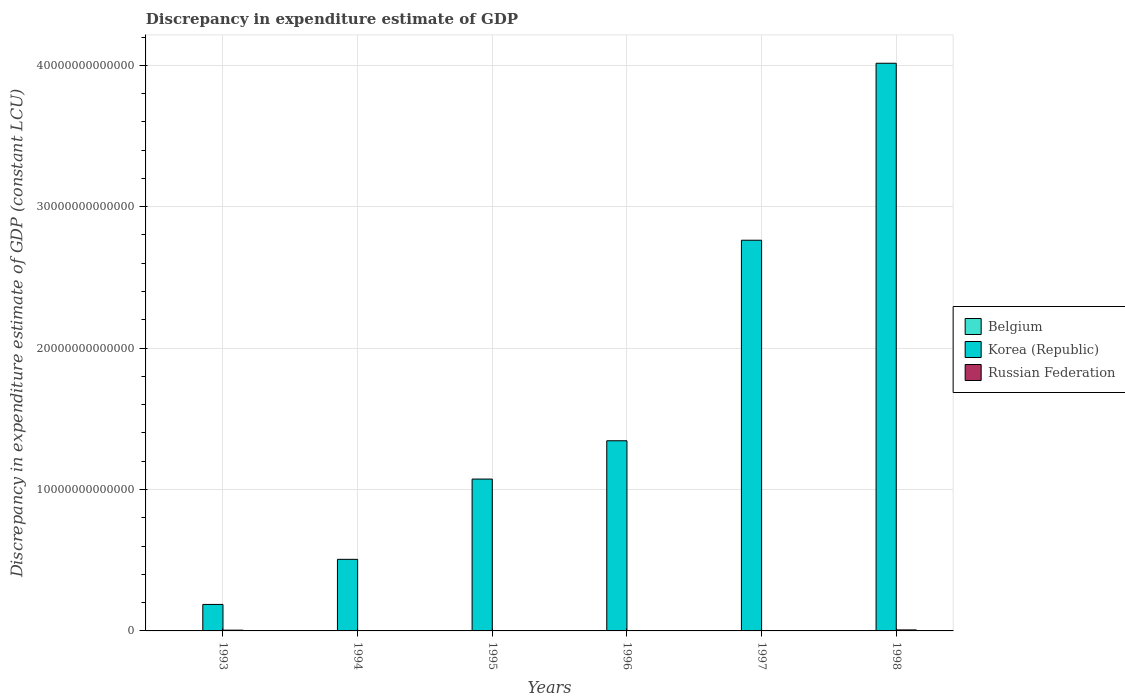How many different coloured bars are there?
Keep it short and to the point. 2. How many bars are there on the 4th tick from the left?
Provide a short and direct response. 1. What is the discrepancy in expenditure estimate of GDP in Belgium in 1996?
Keep it short and to the point. 0. Across all years, what is the maximum discrepancy in expenditure estimate of GDP in Russian Federation?
Your answer should be compact. 7.15e+1. Across all years, what is the minimum discrepancy in expenditure estimate of GDP in Korea (Republic)?
Your answer should be very brief. 1.87e+12. What is the difference between the discrepancy in expenditure estimate of GDP in Russian Federation in 1993 and that in 1998?
Offer a terse response. -1.83e+1. What is the difference between the discrepancy in expenditure estimate of GDP in Korea (Republic) in 1993 and the discrepancy in expenditure estimate of GDP in Belgium in 1996?
Your response must be concise. 1.87e+12. What is the average discrepancy in expenditure estimate of GDP in Russian Federation per year?
Ensure brevity in your answer.  2.37e+1. In the year 1993, what is the difference between the discrepancy in expenditure estimate of GDP in Korea (Republic) and discrepancy in expenditure estimate of GDP in Russian Federation?
Your answer should be compact. 1.82e+12. What is the ratio of the discrepancy in expenditure estimate of GDP in Korea (Republic) in 1994 to that in 1996?
Keep it short and to the point. 0.38. Is the discrepancy in expenditure estimate of GDP in Korea (Republic) in 1996 less than that in 1997?
Offer a terse response. Yes. What is the difference between the highest and the second highest discrepancy in expenditure estimate of GDP in Korea (Republic)?
Keep it short and to the point. 1.25e+13. What is the difference between the highest and the lowest discrepancy in expenditure estimate of GDP in Russian Federation?
Provide a short and direct response. 7.15e+1. Is the sum of the discrepancy in expenditure estimate of GDP in Russian Federation in 1997 and 1998 greater than the maximum discrepancy in expenditure estimate of GDP in Belgium across all years?
Keep it short and to the point. Yes. Is it the case that in every year, the sum of the discrepancy in expenditure estimate of GDP in Belgium and discrepancy in expenditure estimate of GDP in Russian Federation is greater than the discrepancy in expenditure estimate of GDP in Korea (Republic)?
Offer a terse response. No. Are all the bars in the graph horizontal?
Give a very brief answer. No. How many years are there in the graph?
Provide a succinct answer. 6. What is the difference between two consecutive major ticks on the Y-axis?
Your response must be concise. 1.00e+13. Does the graph contain grids?
Provide a short and direct response. Yes. What is the title of the graph?
Your response must be concise. Discrepancy in expenditure estimate of GDP. Does "Other small states" appear as one of the legend labels in the graph?
Your answer should be compact. No. What is the label or title of the Y-axis?
Your response must be concise. Discrepancy in expenditure estimate of GDP (constant LCU). What is the Discrepancy in expenditure estimate of GDP (constant LCU) in Belgium in 1993?
Make the answer very short. 0. What is the Discrepancy in expenditure estimate of GDP (constant LCU) of Korea (Republic) in 1993?
Your answer should be very brief. 1.87e+12. What is the Discrepancy in expenditure estimate of GDP (constant LCU) in Russian Federation in 1993?
Your answer should be compact. 5.32e+1. What is the Discrepancy in expenditure estimate of GDP (constant LCU) in Belgium in 1994?
Keep it short and to the point. 0. What is the Discrepancy in expenditure estimate of GDP (constant LCU) in Korea (Republic) in 1994?
Your response must be concise. 5.06e+12. What is the Discrepancy in expenditure estimate of GDP (constant LCU) of Russian Federation in 1994?
Provide a succinct answer. 0. What is the Discrepancy in expenditure estimate of GDP (constant LCU) of Korea (Republic) in 1995?
Provide a short and direct response. 1.07e+13. What is the Discrepancy in expenditure estimate of GDP (constant LCU) in Russian Federation in 1995?
Your answer should be compact. 0. What is the Discrepancy in expenditure estimate of GDP (constant LCU) in Belgium in 1996?
Provide a succinct answer. 0. What is the Discrepancy in expenditure estimate of GDP (constant LCU) in Korea (Republic) in 1996?
Keep it short and to the point. 1.34e+13. What is the Discrepancy in expenditure estimate of GDP (constant LCU) of Korea (Republic) in 1997?
Your answer should be very brief. 2.76e+13. What is the Discrepancy in expenditure estimate of GDP (constant LCU) in Russian Federation in 1997?
Your answer should be compact. 1.78e+1. What is the Discrepancy in expenditure estimate of GDP (constant LCU) in Belgium in 1998?
Give a very brief answer. 0. What is the Discrepancy in expenditure estimate of GDP (constant LCU) in Korea (Republic) in 1998?
Provide a succinct answer. 4.01e+13. What is the Discrepancy in expenditure estimate of GDP (constant LCU) in Russian Federation in 1998?
Your response must be concise. 7.15e+1. Across all years, what is the maximum Discrepancy in expenditure estimate of GDP (constant LCU) in Korea (Republic)?
Your response must be concise. 4.01e+13. Across all years, what is the maximum Discrepancy in expenditure estimate of GDP (constant LCU) in Russian Federation?
Your answer should be very brief. 7.15e+1. Across all years, what is the minimum Discrepancy in expenditure estimate of GDP (constant LCU) in Korea (Republic)?
Offer a very short reply. 1.87e+12. What is the total Discrepancy in expenditure estimate of GDP (constant LCU) in Belgium in the graph?
Make the answer very short. 0. What is the total Discrepancy in expenditure estimate of GDP (constant LCU) of Korea (Republic) in the graph?
Ensure brevity in your answer.  9.89e+13. What is the total Discrepancy in expenditure estimate of GDP (constant LCU) of Russian Federation in the graph?
Keep it short and to the point. 1.42e+11. What is the difference between the Discrepancy in expenditure estimate of GDP (constant LCU) in Korea (Republic) in 1993 and that in 1994?
Your answer should be very brief. -3.19e+12. What is the difference between the Discrepancy in expenditure estimate of GDP (constant LCU) of Korea (Republic) in 1993 and that in 1995?
Provide a short and direct response. -8.87e+12. What is the difference between the Discrepancy in expenditure estimate of GDP (constant LCU) in Korea (Republic) in 1993 and that in 1996?
Offer a very short reply. -1.16e+13. What is the difference between the Discrepancy in expenditure estimate of GDP (constant LCU) of Korea (Republic) in 1993 and that in 1997?
Your answer should be compact. -2.58e+13. What is the difference between the Discrepancy in expenditure estimate of GDP (constant LCU) in Russian Federation in 1993 and that in 1997?
Make the answer very short. 3.54e+1. What is the difference between the Discrepancy in expenditure estimate of GDP (constant LCU) of Korea (Republic) in 1993 and that in 1998?
Your answer should be very brief. -3.83e+13. What is the difference between the Discrepancy in expenditure estimate of GDP (constant LCU) of Russian Federation in 1993 and that in 1998?
Ensure brevity in your answer.  -1.83e+1. What is the difference between the Discrepancy in expenditure estimate of GDP (constant LCU) in Korea (Republic) in 1994 and that in 1995?
Your response must be concise. -5.68e+12. What is the difference between the Discrepancy in expenditure estimate of GDP (constant LCU) in Korea (Republic) in 1994 and that in 1996?
Give a very brief answer. -8.39e+12. What is the difference between the Discrepancy in expenditure estimate of GDP (constant LCU) in Korea (Republic) in 1994 and that in 1997?
Provide a short and direct response. -2.26e+13. What is the difference between the Discrepancy in expenditure estimate of GDP (constant LCU) in Korea (Republic) in 1994 and that in 1998?
Provide a short and direct response. -3.51e+13. What is the difference between the Discrepancy in expenditure estimate of GDP (constant LCU) of Korea (Republic) in 1995 and that in 1996?
Your response must be concise. -2.71e+12. What is the difference between the Discrepancy in expenditure estimate of GDP (constant LCU) in Korea (Republic) in 1995 and that in 1997?
Your response must be concise. -1.69e+13. What is the difference between the Discrepancy in expenditure estimate of GDP (constant LCU) in Korea (Republic) in 1995 and that in 1998?
Keep it short and to the point. -2.94e+13. What is the difference between the Discrepancy in expenditure estimate of GDP (constant LCU) of Korea (Republic) in 1996 and that in 1997?
Provide a short and direct response. -1.42e+13. What is the difference between the Discrepancy in expenditure estimate of GDP (constant LCU) in Korea (Republic) in 1996 and that in 1998?
Make the answer very short. -2.67e+13. What is the difference between the Discrepancy in expenditure estimate of GDP (constant LCU) of Korea (Republic) in 1997 and that in 1998?
Provide a short and direct response. -1.25e+13. What is the difference between the Discrepancy in expenditure estimate of GDP (constant LCU) of Russian Federation in 1997 and that in 1998?
Provide a short and direct response. -5.37e+1. What is the difference between the Discrepancy in expenditure estimate of GDP (constant LCU) of Korea (Republic) in 1993 and the Discrepancy in expenditure estimate of GDP (constant LCU) of Russian Federation in 1997?
Offer a very short reply. 1.86e+12. What is the difference between the Discrepancy in expenditure estimate of GDP (constant LCU) in Korea (Republic) in 1993 and the Discrepancy in expenditure estimate of GDP (constant LCU) in Russian Federation in 1998?
Make the answer very short. 1.80e+12. What is the difference between the Discrepancy in expenditure estimate of GDP (constant LCU) of Korea (Republic) in 1994 and the Discrepancy in expenditure estimate of GDP (constant LCU) of Russian Federation in 1997?
Your answer should be compact. 5.05e+12. What is the difference between the Discrepancy in expenditure estimate of GDP (constant LCU) of Korea (Republic) in 1994 and the Discrepancy in expenditure estimate of GDP (constant LCU) of Russian Federation in 1998?
Your response must be concise. 4.99e+12. What is the difference between the Discrepancy in expenditure estimate of GDP (constant LCU) of Korea (Republic) in 1995 and the Discrepancy in expenditure estimate of GDP (constant LCU) of Russian Federation in 1997?
Your answer should be compact. 1.07e+13. What is the difference between the Discrepancy in expenditure estimate of GDP (constant LCU) in Korea (Republic) in 1995 and the Discrepancy in expenditure estimate of GDP (constant LCU) in Russian Federation in 1998?
Keep it short and to the point. 1.07e+13. What is the difference between the Discrepancy in expenditure estimate of GDP (constant LCU) in Korea (Republic) in 1996 and the Discrepancy in expenditure estimate of GDP (constant LCU) in Russian Federation in 1997?
Provide a short and direct response. 1.34e+13. What is the difference between the Discrepancy in expenditure estimate of GDP (constant LCU) in Korea (Republic) in 1996 and the Discrepancy in expenditure estimate of GDP (constant LCU) in Russian Federation in 1998?
Your answer should be very brief. 1.34e+13. What is the difference between the Discrepancy in expenditure estimate of GDP (constant LCU) of Korea (Republic) in 1997 and the Discrepancy in expenditure estimate of GDP (constant LCU) of Russian Federation in 1998?
Offer a terse response. 2.76e+13. What is the average Discrepancy in expenditure estimate of GDP (constant LCU) in Korea (Republic) per year?
Provide a short and direct response. 1.65e+13. What is the average Discrepancy in expenditure estimate of GDP (constant LCU) of Russian Federation per year?
Your response must be concise. 2.37e+1. In the year 1993, what is the difference between the Discrepancy in expenditure estimate of GDP (constant LCU) in Korea (Republic) and Discrepancy in expenditure estimate of GDP (constant LCU) in Russian Federation?
Ensure brevity in your answer.  1.82e+12. In the year 1997, what is the difference between the Discrepancy in expenditure estimate of GDP (constant LCU) in Korea (Republic) and Discrepancy in expenditure estimate of GDP (constant LCU) in Russian Federation?
Provide a short and direct response. 2.76e+13. In the year 1998, what is the difference between the Discrepancy in expenditure estimate of GDP (constant LCU) of Korea (Republic) and Discrepancy in expenditure estimate of GDP (constant LCU) of Russian Federation?
Provide a short and direct response. 4.01e+13. What is the ratio of the Discrepancy in expenditure estimate of GDP (constant LCU) in Korea (Republic) in 1993 to that in 1994?
Keep it short and to the point. 0.37. What is the ratio of the Discrepancy in expenditure estimate of GDP (constant LCU) of Korea (Republic) in 1993 to that in 1995?
Provide a short and direct response. 0.17. What is the ratio of the Discrepancy in expenditure estimate of GDP (constant LCU) in Korea (Republic) in 1993 to that in 1996?
Keep it short and to the point. 0.14. What is the ratio of the Discrepancy in expenditure estimate of GDP (constant LCU) of Korea (Republic) in 1993 to that in 1997?
Your answer should be very brief. 0.07. What is the ratio of the Discrepancy in expenditure estimate of GDP (constant LCU) in Russian Federation in 1993 to that in 1997?
Give a very brief answer. 2.99. What is the ratio of the Discrepancy in expenditure estimate of GDP (constant LCU) of Korea (Republic) in 1993 to that in 1998?
Your answer should be compact. 0.05. What is the ratio of the Discrepancy in expenditure estimate of GDP (constant LCU) in Russian Federation in 1993 to that in 1998?
Make the answer very short. 0.74. What is the ratio of the Discrepancy in expenditure estimate of GDP (constant LCU) in Korea (Republic) in 1994 to that in 1995?
Make the answer very short. 0.47. What is the ratio of the Discrepancy in expenditure estimate of GDP (constant LCU) in Korea (Republic) in 1994 to that in 1996?
Offer a terse response. 0.38. What is the ratio of the Discrepancy in expenditure estimate of GDP (constant LCU) of Korea (Republic) in 1994 to that in 1997?
Keep it short and to the point. 0.18. What is the ratio of the Discrepancy in expenditure estimate of GDP (constant LCU) of Korea (Republic) in 1994 to that in 1998?
Ensure brevity in your answer.  0.13. What is the ratio of the Discrepancy in expenditure estimate of GDP (constant LCU) in Korea (Republic) in 1995 to that in 1996?
Offer a very short reply. 0.8. What is the ratio of the Discrepancy in expenditure estimate of GDP (constant LCU) of Korea (Republic) in 1995 to that in 1997?
Offer a very short reply. 0.39. What is the ratio of the Discrepancy in expenditure estimate of GDP (constant LCU) in Korea (Republic) in 1995 to that in 1998?
Your answer should be compact. 0.27. What is the ratio of the Discrepancy in expenditure estimate of GDP (constant LCU) in Korea (Republic) in 1996 to that in 1997?
Provide a succinct answer. 0.49. What is the ratio of the Discrepancy in expenditure estimate of GDP (constant LCU) of Korea (Republic) in 1996 to that in 1998?
Offer a very short reply. 0.34. What is the ratio of the Discrepancy in expenditure estimate of GDP (constant LCU) of Korea (Republic) in 1997 to that in 1998?
Make the answer very short. 0.69. What is the ratio of the Discrepancy in expenditure estimate of GDP (constant LCU) of Russian Federation in 1997 to that in 1998?
Offer a terse response. 0.25. What is the difference between the highest and the second highest Discrepancy in expenditure estimate of GDP (constant LCU) in Korea (Republic)?
Your response must be concise. 1.25e+13. What is the difference between the highest and the second highest Discrepancy in expenditure estimate of GDP (constant LCU) in Russian Federation?
Make the answer very short. 1.83e+1. What is the difference between the highest and the lowest Discrepancy in expenditure estimate of GDP (constant LCU) in Korea (Republic)?
Your answer should be compact. 3.83e+13. What is the difference between the highest and the lowest Discrepancy in expenditure estimate of GDP (constant LCU) of Russian Federation?
Your answer should be very brief. 7.15e+1. 